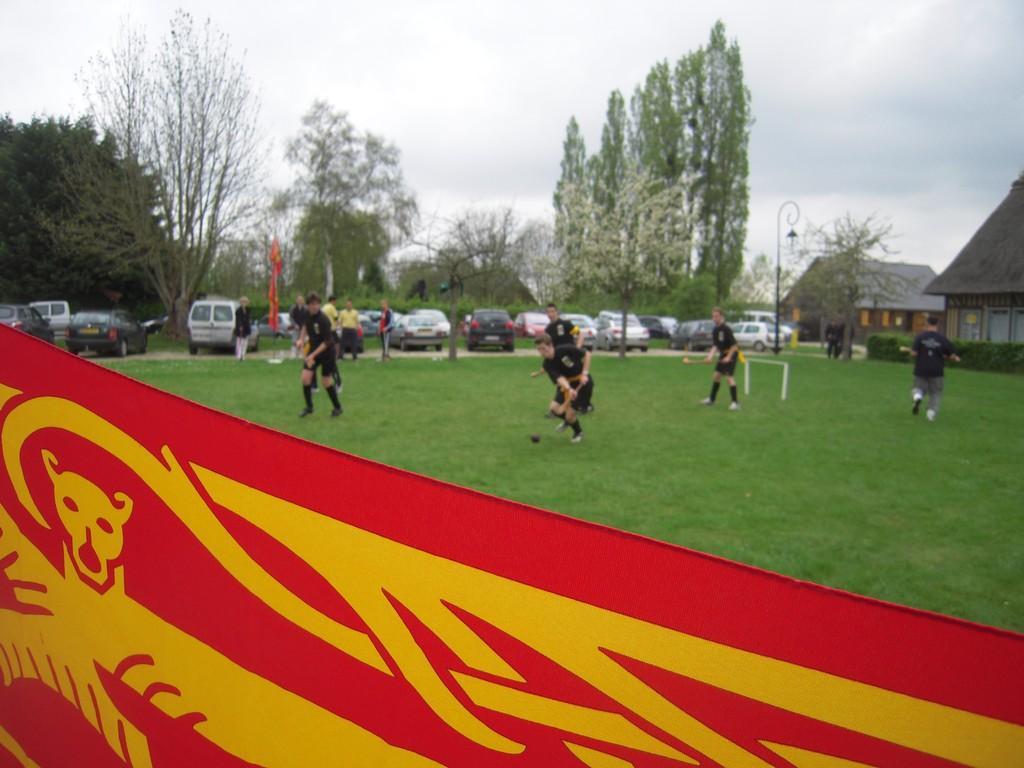Please provide a concise description of this image. In this image we can see men are playing a game on the grassy land. In the background of the image, we can see people, cars, poles, buildings and trees. At the top of the image, the sky is covered with the clouds. There is a flag at the bottom of the image. 